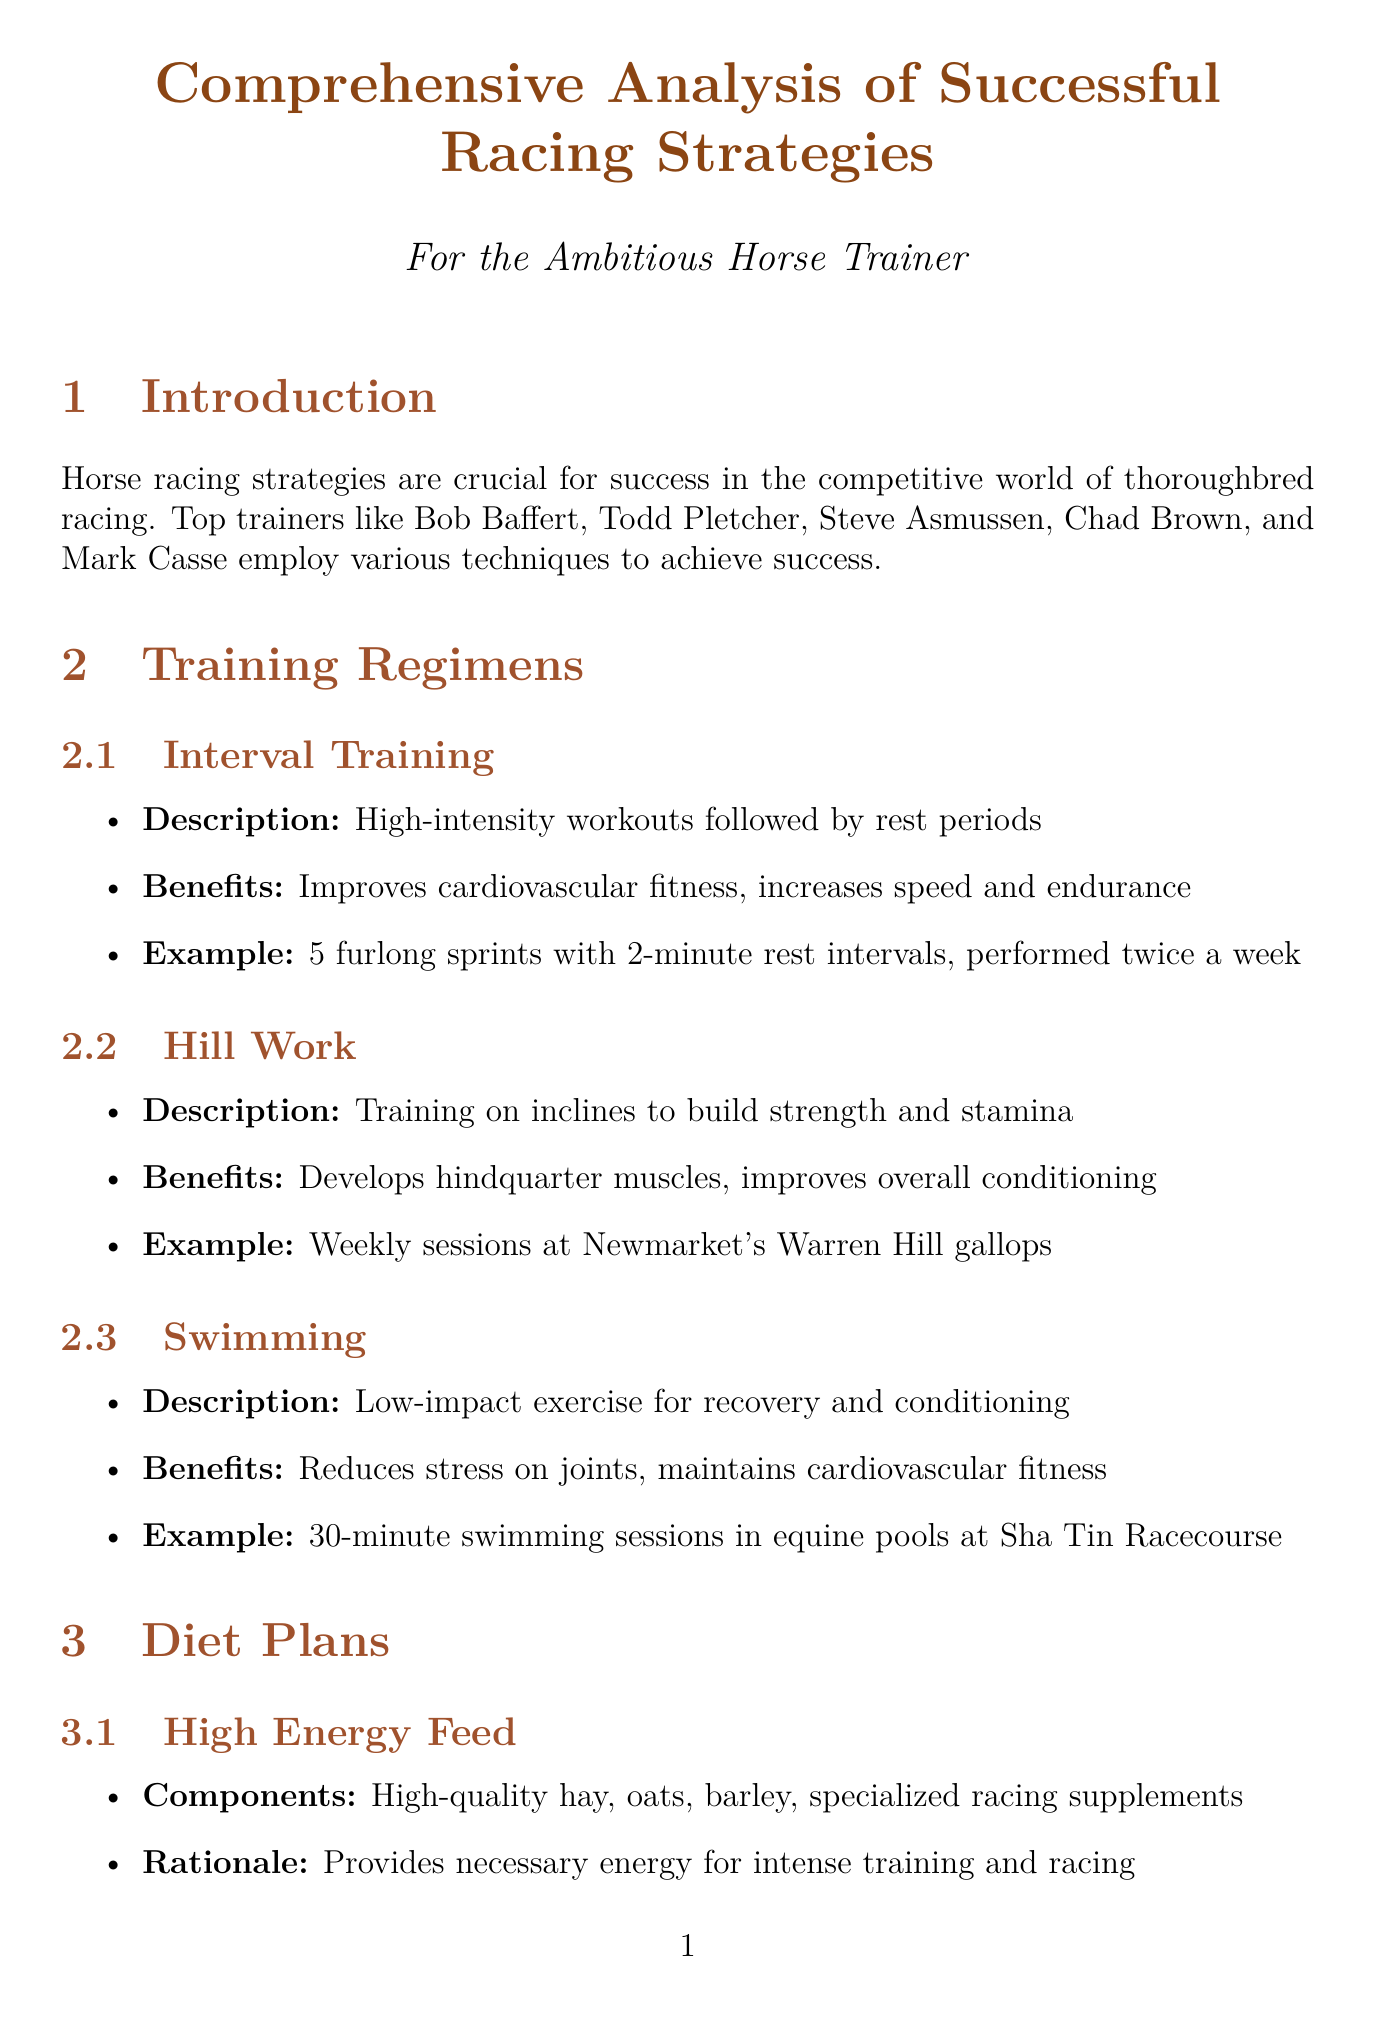What are the names of top trainers? The document lists top trainers in horse racing, which include Bob Baffert, Todd Pletcher, Steve Asmussen, Chad Brown, and Mark Casse.
Answer: Bob Baffert, Todd Pletcher, Steve Asmussen, Chad Brown, Mark Casse What is a benefit of interval training? The benefits of interval training include improving cardiovascular fitness and increasing speed and endurance.
Answer: Improves cardiovascular fitness What is the importance of hydration? Hydration is crucial for maintaining electrolyte balance and preventing fatigue, according to the document.
Answer: Maintaining electrolyte balance What type of preparation is related to reducing anxiety in races? The document mentions mental conditioning methods such as exposure to race day sounds and simulated starting gate practice as methods to reduce anxiety.
Answer: Mental conditioning Who trained American Pharoah? The document specifies that Bob Baffert trained American Pharoah, who won the 2015 Triple Crown.
Answer: Bob Baffert What are some tools used for technology integration in training? The document highlights tools like GPS tracking devices, heart rate monitors, and gait analysis software for technology integration.
Answer: GPS tracking devices How often are swimming sessions performed according to the training regimens? The document provides an example of 30-minute swimming sessions taking place, but does not specify how often.
Answer: Weekly What does the case study of Enable highlight? The case study emphasizes tailored exercise routines and mental preparation for international travel as key strategies used by trainer John Gosden.
Answer: Tailored exercise routines What is a common addition to horse diets for recovery? The document lists common additions to diets, including Vitamin E and Omega-3 fatty acids for supporting muscle recovery.
Answer: Vitamin E 